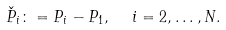<formula> <loc_0><loc_0><loc_500><loc_500>\check { P } _ { i } \colon = P _ { i } - P _ { 1 } , \ \ i = 2 , \dots , N .</formula> 